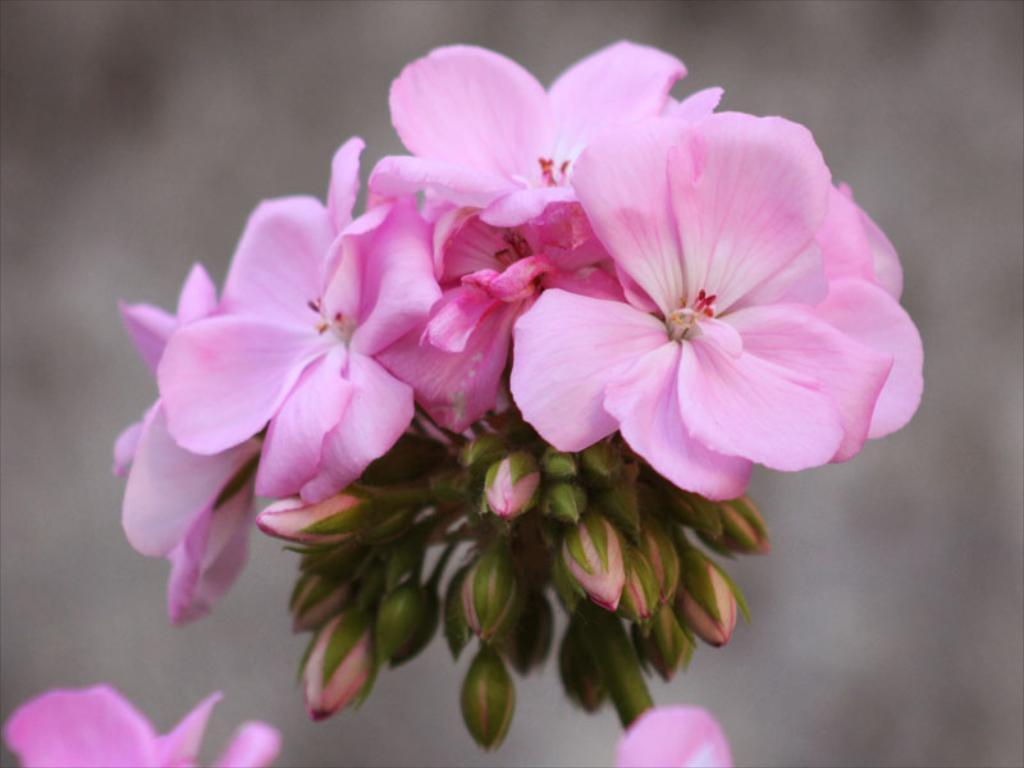What type of flowers can be seen in the foreground of the image? There are pink flowers in the foreground of the image. What stage of growth are the flowers on the plant in the foreground? There are buds on a plant in the foreground of the image. Can you describe the background of the image? The background of the image is blurred. How many turkeys can be seen on the coast in the image? There are no turkeys or coast visible in the image; it features pink flowers and buds on a plant in the foreground with a blurred background. 